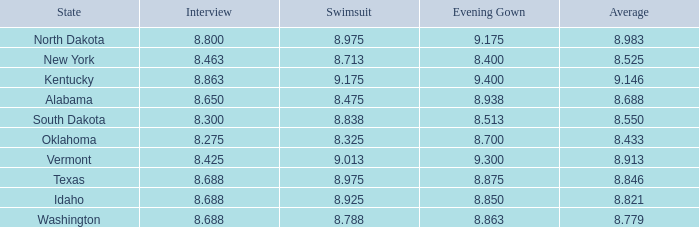What is the minimum evening score of the participant with an evening dress below None. 